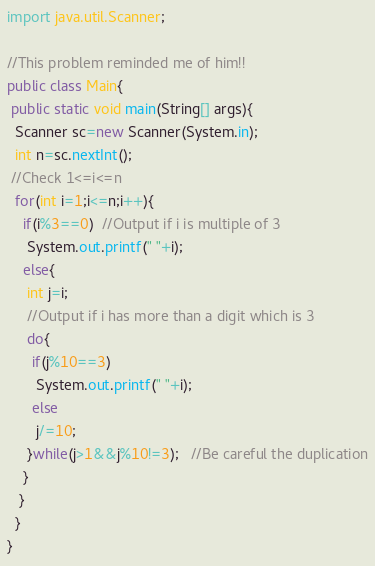Convert code to text. <code><loc_0><loc_0><loc_500><loc_500><_Java_>import java.util.Scanner;

//This problem reminded me of him!!
public class Main{
 public static void main(String[] args){
  Scanner sc=new Scanner(System.in);
  int n=sc.nextInt();
 //Check 1<=i<=n
  for(int i=1;i<=n;i++){
    if(i%3==0)  //Output if i is multiple of 3
     System.out.printf(" "+i);
    else{
     int j=i;
     //Output if i has more than a digit which is 3
     do{
      if(j%10==3)
       System.out.printf(" "+i);
      else
       j/=10;
     }while(j>1&&j%10!=3);   //Be careful the duplication
    }
   }
  }
}</code> 